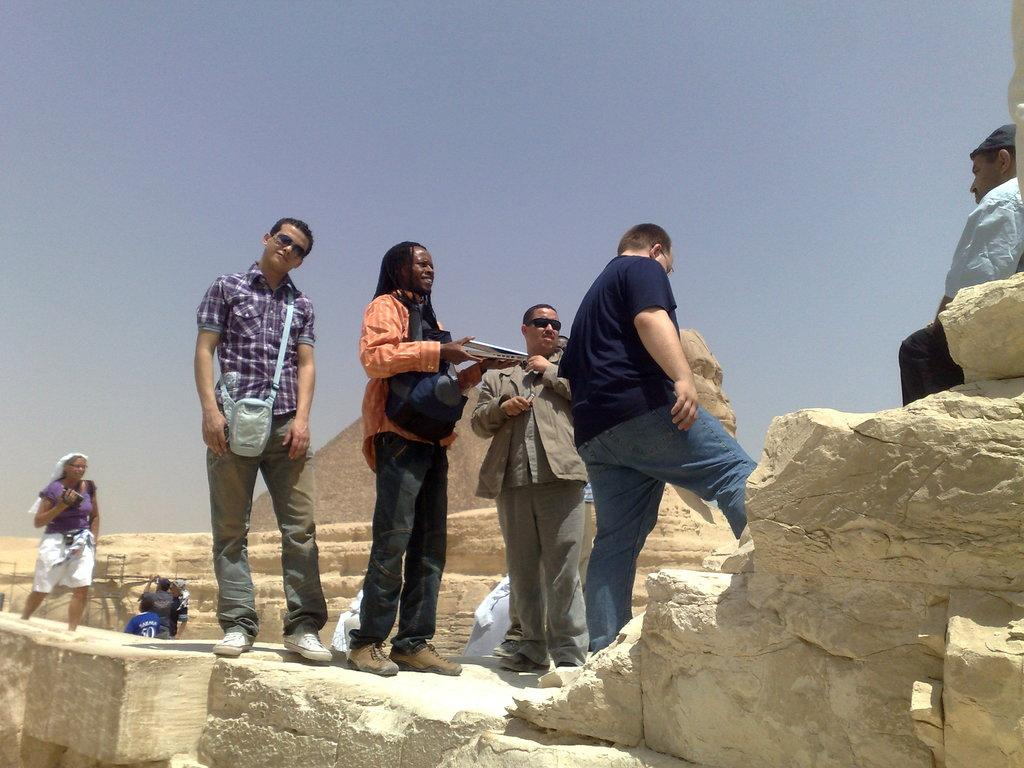What are the people in the foreground of the image doing? There are people standing in the foreground area of the image. Where is the person sitting in the image? There is a person sitting on the right side of the image. Can you describe the background of the image? There are people in the background of the image, and there is a pyramid structure and the sky visible. What type of seed is being planted by the person sitting in the image? There is no seed or planting activity depicted in the image; it only shows people standing and sitting. What historical event is being commemorated by the people in the image? There is no indication of a historical event or commemoration in the image. 